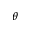<formula> <loc_0><loc_0><loc_500><loc_500>\theta</formula> 